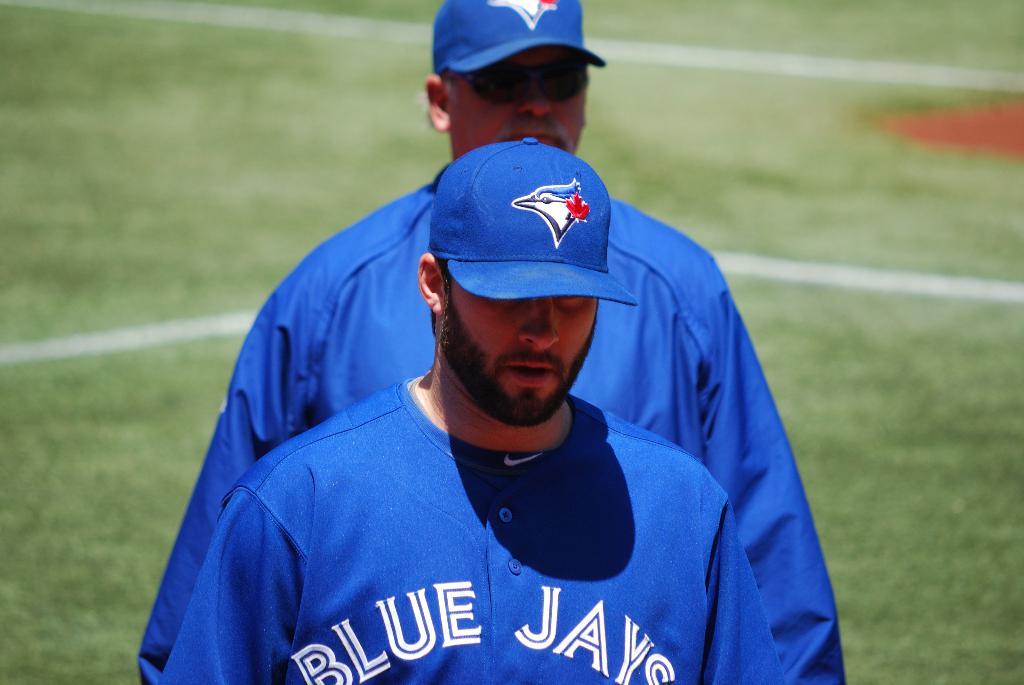What team is the baseball player a part of?
Ensure brevity in your answer.  Blue jays. 